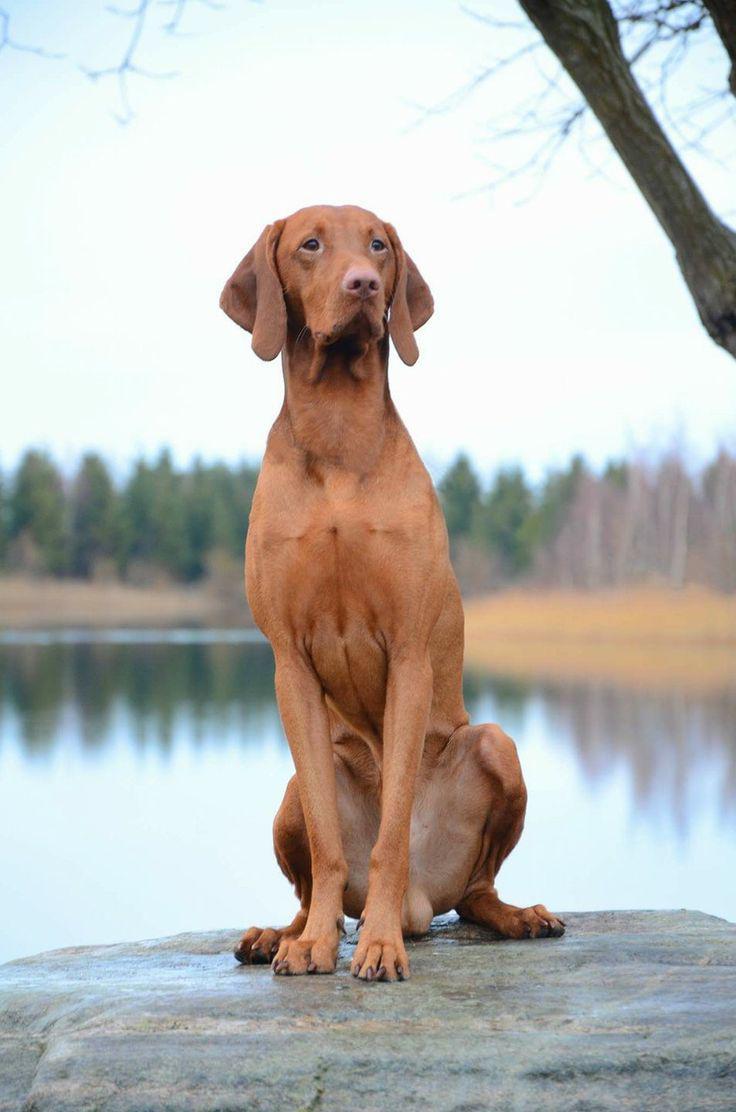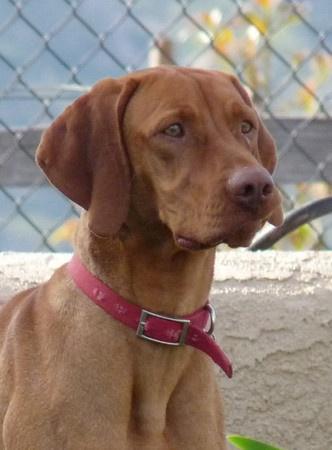The first image is the image on the left, the second image is the image on the right. Given the left and right images, does the statement "Each image contains only one dog, the left image features a dog turned forward and sitting upright, and the right image features a rightward-turned dog wearing a collar." hold true? Answer yes or no. Yes. The first image is the image on the left, the second image is the image on the right. Analyze the images presented: Is the assertion "A single dog in the image on the left is sitting up." valid? Answer yes or no. Yes. 